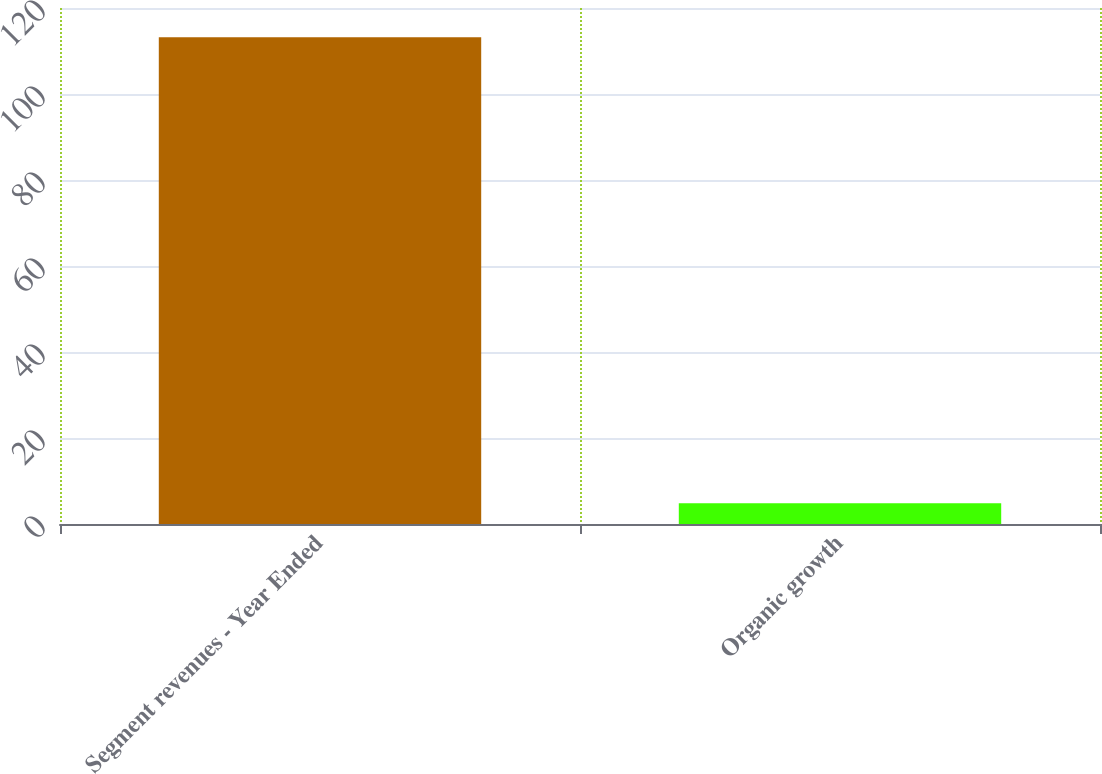Convert chart. <chart><loc_0><loc_0><loc_500><loc_500><bar_chart><fcel>Segment revenues - Year Ended<fcel>Organic growth<nl><fcel>113.2<fcel>4.8<nl></chart> 